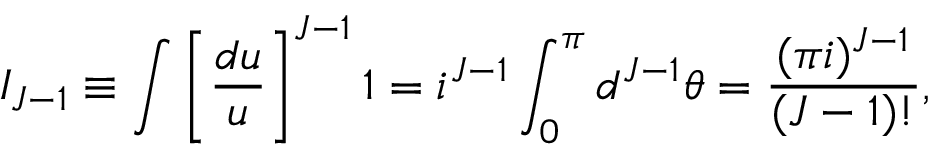Convert formula to latex. <formula><loc_0><loc_0><loc_500><loc_500>I _ { J - 1 } \equiv \int \left [ \frac { d u } { u } \right ] ^ { J - 1 } 1 = i ^ { J - 1 } \int _ { 0 } ^ { \pi } d ^ { J - 1 } \theta = \frac { ( \pi i ) ^ { J - 1 } } { ( J - 1 ) ! } ,</formula> 